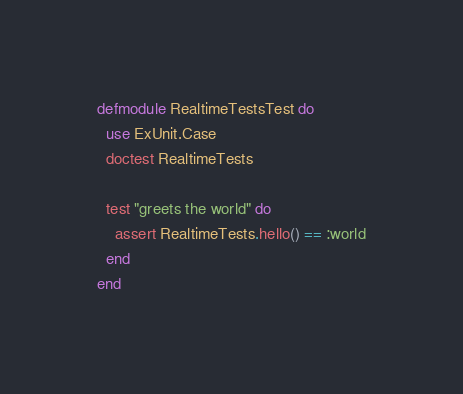Convert code to text. <code><loc_0><loc_0><loc_500><loc_500><_Elixir_>defmodule RealtimeTestsTest do
  use ExUnit.Case
  doctest RealtimeTests

  test "greets the world" do
    assert RealtimeTests.hello() == :world
  end
end
</code> 